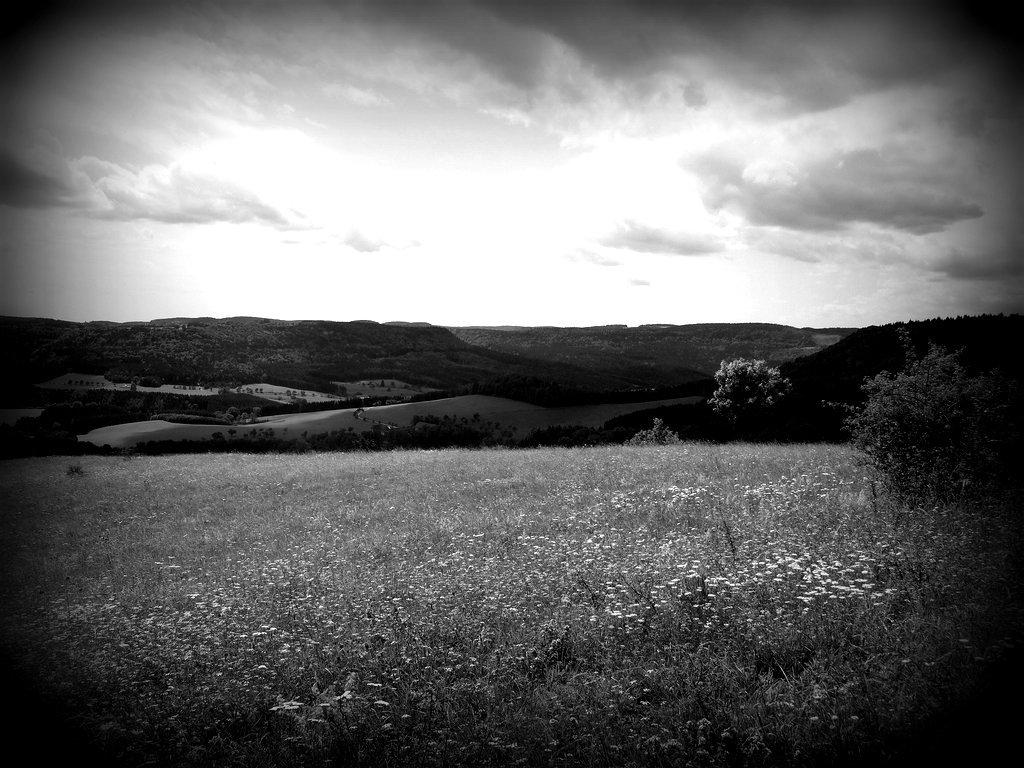What is the color scheme of the image? The image is black and white. What type of natural elements can be seen in the image? There are plants in the image. What can be seen in the distance in the image? There are hills in the background of the image. What type of mint is growing on the hills in the image? There is no mint present in the image; it only features plants and hills. 